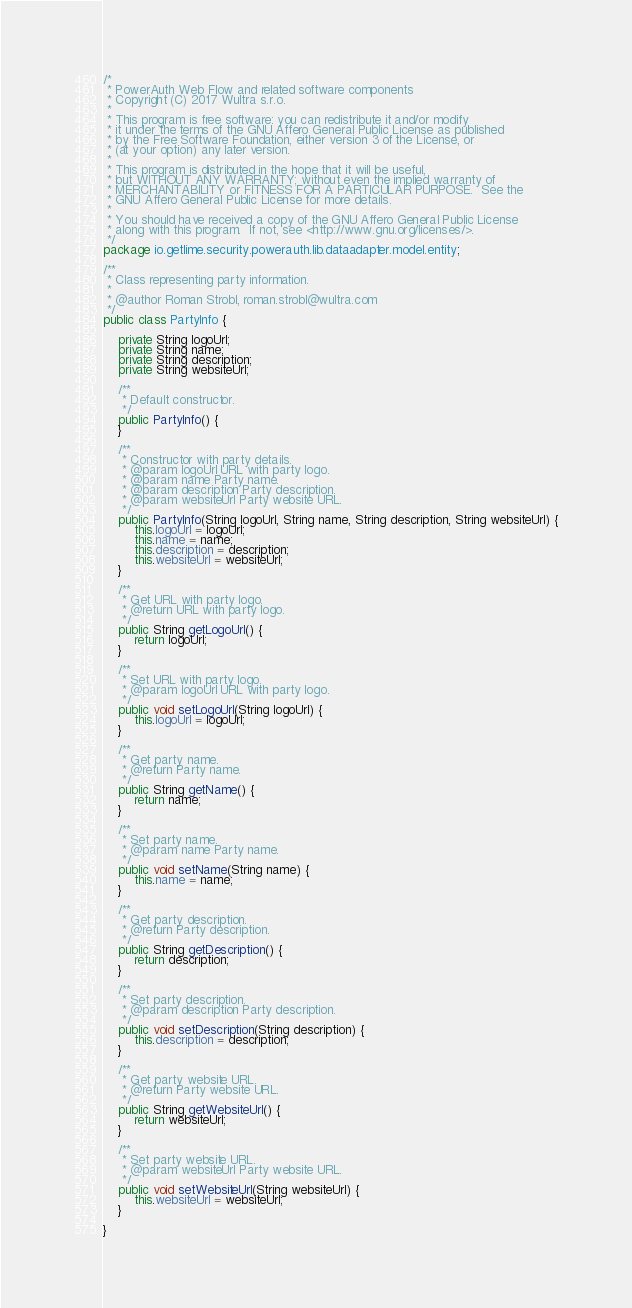Convert code to text. <code><loc_0><loc_0><loc_500><loc_500><_Java_>/*
 * PowerAuth Web Flow and related software components
 * Copyright (C) 2017 Wultra s.r.o.
 *
 * This program is free software: you can redistribute it and/or modify
 * it under the terms of the GNU Affero General Public License as published
 * by the Free Software Foundation, either version 3 of the License, or
 * (at your option) any later version.
 *
 * This program is distributed in the hope that it will be useful,
 * but WITHOUT ANY WARRANTY; without even the implied warranty of
 * MERCHANTABILITY or FITNESS FOR A PARTICULAR PURPOSE.  See the
 * GNU Affero General Public License for more details.
 *
 * You should have received a copy of the GNU Affero General Public License
 * along with this program.  If not, see <http://www.gnu.org/licenses/>.
 */
package io.getlime.security.powerauth.lib.dataadapter.model.entity;

/**
 * Class representing party information.
 *
 * @author Roman Strobl, roman.strobl@wultra.com
 */
public class PartyInfo {

    private String logoUrl;
    private String name;
    private String description;
    private String websiteUrl;

    /**
     * Default constructor.
     */
    public PartyInfo() {
    }

    /**
     * Constructor with party details.
     * @param logoUrl URL with party logo.
     * @param name Party name.
     * @param description Party description.
     * @param websiteUrl Party website URL.
     */
    public PartyInfo(String logoUrl, String name, String description, String websiteUrl) {
        this.logoUrl = logoUrl;
        this.name = name;
        this.description = description;
        this.websiteUrl = websiteUrl;
    }

    /**
     * Get URL with party logo.
     * @return URL with party logo.
     */
    public String getLogoUrl() {
        return logoUrl;
    }

    /**
     * Set URL with party logo.
     * @param logoUrl URL with party logo.
     */
    public void setLogoUrl(String logoUrl) {
        this.logoUrl = logoUrl;
    }

    /**
     * Get party name.
     * @return Party name.
     */
    public String getName() {
        return name;
    }

    /**
     * Set party name.
     * @param name Party name.
     */
    public void setName(String name) {
        this.name = name;
    }

    /**
     * Get party description.
     * @return Party description.
     */
    public String getDescription() {
        return description;
    }

    /**
     * Set party description.
     * @param description Party description.
     */
    public void setDescription(String description) {
        this.description = description;
    }

    /**
     * Get party website URL.
     * @return Party website URL.
     */
    public String getWebsiteUrl() {
        return websiteUrl;
    }

    /**
     * Set party website URL.
     * @param websiteUrl Party website URL.
     */
    public void setWebsiteUrl(String websiteUrl) {
        this.websiteUrl = websiteUrl;
    }

}
</code> 